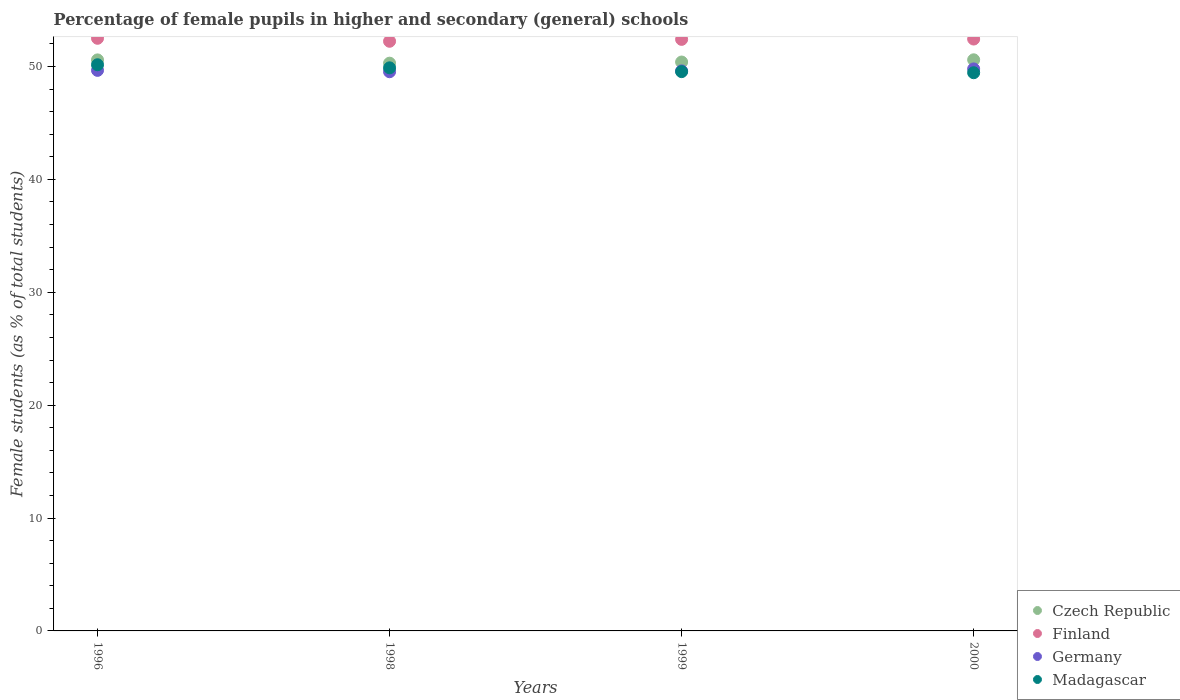What is the percentage of female pupils in higher and secondary schools in Germany in 1998?
Provide a succinct answer. 49.54. Across all years, what is the maximum percentage of female pupils in higher and secondary schools in Czech Republic?
Give a very brief answer. 50.6. Across all years, what is the minimum percentage of female pupils in higher and secondary schools in Germany?
Make the answer very short. 49.54. In which year was the percentage of female pupils in higher and secondary schools in Germany maximum?
Make the answer very short. 2000. What is the total percentage of female pupils in higher and secondary schools in Finland in the graph?
Your answer should be compact. 209.58. What is the difference between the percentage of female pupils in higher and secondary schools in Finland in 1996 and that in 1998?
Keep it short and to the point. 0.26. What is the difference between the percentage of female pupils in higher and secondary schools in Finland in 1998 and the percentage of female pupils in higher and secondary schools in Czech Republic in 1996?
Your answer should be compact. 1.65. What is the average percentage of female pupils in higher and secondary schools in Madagascar per year?
Your answer should be compact. 49.76. In the year 2000, what is the difference between the percentage of female pupils in higher and secondary schools in Czech Republic and percentage of female pupils in higher and secondary schools in Finland?
Ensure brevity in your answer.  -1.84. What is the ratio of the percentage of female pupils in higher and secondary schools in Finland in 1999 to that in 2000?
Your answer should be compact. 1. Is the percentage of female pupils in higher and secondary schools in Finland in 1999 less than that in 2000?
Your answer should be very brief. Yes. Is the difference between the percentage of female pupils in higher and secondary schools in Czech Republic in 1996 and 1998 greater than the difference between the percentage of female pupils in higher and secondary schools in Finland in 1996 and 1998?
Provide a short and direct response. Yes. What is the difference between the highest and the second highest percentage of female pupils in higher and secondary schools in Czech Republic?
Your response must be concise. 0.01. What is the difference between the highest and the lowest percentage of female pupils in higher and secondary schools in Germany?
Your response must be concise. 0.25. Is it the case that in every year, the sum of the percentage of female pupils in higher and secondary schools in Germany and percentage of female pupils in higher and secondary schools in Madagascar  is greater than the sum of percentage of female pupils in higher and secondary schools in Czech Republic and percentage of female pupils in higher and secondary schools in Finland?
Your response must be concise. No. Does the percentage of female pupils in higher and secondary schools in Madagascar monotonically increase over the years?
Provide a short and direct response. No. Is the percentage of female pupils in higher and secondary schools in Finland strictly less than the percentage of female pupils in higher and secondary schools in Czech Republic over the years?
Your answer should be very brief. No. Are the values on the major ticks of Y-axis written in scientific E-notation?
Keep it short and to the point. No. Does the graph contain grids?
Ensure brevity in your answer.  No. Where does the legend appear in the graph?
Keep it short and to the point. Bottom right. How many legend labels are there?
Offer a very short reply. 4. What is the title of the graph?
Provide a short and direct response. Percentage of female pupils in higher and secondary (general) schools. Does "Jordan" appear as one of the legend labels in the graph?
Your response must be concise. No. What is the label or title of the Y-axis?
Ensure brevity in your answer.  Female students (as % of total students). What is the Female students (as % of total students) in Czech Republic in 1996?
Your answer should be very brief. 50.59. What is the Female students (as % of total students) of Finland in 1996?
Provide a short and direct response. 52.5. What is the Female students (as % of total students) of Germany in 1996?
Your answer should be very brief. 49.66. What is the Female students (as % of total students) in Madagascar in 1996?
Give a very brief answer. 50.16. What is the Female students (as % of total students) in Czech Republic in 1998?
Offer a very short reply. 50.3. What is the Female students (as % of total students) in Finland in 1998?
Provide a short and direct response. 52.24. What is the Female students (as % of total students) in Germany in 1998?
Ensure brevity in your answer.  49.54. What is the Female students (as % of total students) in Madagascar in 1998?
Offer a very short reply. 49.88. What is the Female students (as % of total students) in Czech Republic in 1999?
Provide a succinct answer. 50.4. What is the Female students (as % of total students) in Finland in 1999?
Offer a terse response. 52.41. What is the Female students (as % of total students) in Germany in 1999?
Offer a terse response. 49.61. What is the Female students (as % of total students) in Madagascar in 1999?
Your answer should be compact. 49.55. What is the Female students (as % of total students) in Czech Republic in 2000?
Provide a succinct answer. 50.6. What is the Female students (as % of total students) in Finland in 2000?
Your answer should be compact. 52.44. What is the Female students (as % of total students) in Germany in 2000?
Make the answer very short. 49.79. What is the Female students (as % of total students) of Madagascar in 2000?
Offer a very short reply. 49.45. Across all years, what is the maximum Female students (as % of total students) of Czech Republic?
Ensure brevity in your answer.  50.6. Across all years, what is the maximum Female students (as % of total students) of Finland?
Your answer should be compact. 52.5. Across all years, what is the maximum Female students (as % of total students) in Germany?
Keep it short and to the point. 49.79. Across all years, what is the maximum Female students (as % of total students) of Madagascar?
Your response must be concise. 50.16. Across all years, what is the minimum Female students (as % of total students) in Czech Republic?
Ensure brevity in your answer.  50.3. Across all years, what is the minimum Female students (as % of total students) in Finland?
Your answer should be very brief. 52.24. Across all years, what is the minimum Female students (as % of total students) of Germany?
Make the answer very short. 49.54. Across all years, what is the minimum Female students (as % of total students) of Madagascar?
Provide a short and direct response. 49.45. What is the total Female students (as % of total students) in Czech Republic in the graph?
Provide a succinct answer. 201.88. What is the total Female students (as % of total students) of Finland in the graph?
Ensure brevity in your answer.  209.58. What is the total Female students (as % of total students) of Germany in the graph?
Provide a short and direct response. 198.6. What is the total Female students (as % of total students) of Madagascar in the graph?
Make the answer very short. 199.04. What is the difference between the Female students (as % of total students) in Czech Republic in 1996 and that in 1998?
Offer a very short reply. 0.29. What is the difference between the Female students (as % of total students) of Finland in 1996 and that in 1998?
Your answer should be compact. 0.26. What is the difference between the Female students (as % of total students) in Germany in 1996 and that in 1998?
Offer a terse response. 0.12. What is the difference between the Female students (as % of total students) in Madagascar in 1996 and that in 1998?
Your answer should be compact. 0.27. What is the difference between the Female students (as % of total students) of Czech Republic in 1996 and that in 1999?
Your answer should be compact. 0.19. What is the difference between the Female students (as % of total students) of Finland in 1996 and that in 1999?
Your answer should be very brief. 0.1. What is the difference between the Female students (as % of total students) of Germany in 1996 and that in 1999?
Ensure brevity in your answer.  0.05. What is the difference between the Female students (as % of total students) of Madagascar in 1996 and that in 1999?
Offer a terse response. 0.61. What is the difference between the Female students (as % of total students) in Czech Republic in 1996 and that in 2000?
Ensure brevity in your answer.  -0.01. What is the difference between the Female students (as % of total students) of Finland in 1996 and that in 2000?
Make the answer very short. 0.07. What is the difference between the Female students (as % of total students) of Germany in 1996 and that in 2000?
Keep it short and to the point. -0.13. What is the difference between the Female students (as % of total students) of Madagascar in 1996 and that in 2000?
Your response must be concise. 0.71. What is the difference between the Female students (as % of total students) of Czech Republic in 1998 and that in 1999?
Offer a very short reply. -0.1. What is the difference between the Female students (as % of total students) of Finland in 1998 and that in 1999?
Your response must be concise. -0.17. What is the difference between the Female students (as % of total students) in Germany in 1998 and that in 1999?
Provide a succinct answer. -0.07. What is the difference between the Female students (as % of total students) in Madagascar in 1998 and that in 1999?
Offer a terse response. 0.34. What is the difference between the Female students (as % of total students) of Czech Republic in 1998 and that in 2000?
Offer a very short reply. -0.3. What is the difference between the Female students (as % of total students) in Finland in 1998 and that in 2000?
Provide a succinct answer. -0.2. What is the difference between the Female students (as % of total students) in Madagascar in 1998 and that in 2000?
Provide a succinct answer. 0.43. What is the difference between the Female students (as % of total students) in Czech Republic in 1999 and that in 2000?
Offer a very short reply. -0.2. What is the difference between the Female students (as % of total students) of Finland in 1999 and that in 2000?
Give a very brief answer. -0.03. What is the difference between the Female students (as % of total students) in Germany in 1999 and that in 2000?
Ensure brevity in your answer.  -0.18. What is the difference between the Female students (as % of total students) in Madagascar in 1999 and that in 2000?
Your answer should be compact. 0.1. What is the difference between the Female students (as % of total students) of Czech Republic in 1996 and the Female students (as % of total students) of Finland in 1998?
Offer a very short reply. -1.65. What is the difference between the Female students (as % of total students) in Czech Republic in 1996 and the Female students (as % of total students) in Germany in 1998?
Offer a terse response. 1.05. What is the difference between the Female students (as % of total students) in Czech Republic in 1996 and the Female students (as % of total students) in Madagascar in 1998?
Keep it short and to the point. 0.7. What is the difference between the Female students (as % of total students) of Finland in 1996 and the Female students (as % of total students) of Germany in 1998?
Offer a very short reply. 2.96. What is the difference between the Female students (as % of total students) of Finland in 1996 and the Female students (as % of total students) of Madagascar in 1998?
Ensure brevity in your answer.  2.62. What is the difference between the Female students (as % of total students) in Germany in 1996 and the Female students (as % of total students) in Madagascar in 1998?
Ensure brevity in your answer.  -0.22. What is the difference between the Female students (as % of total students) in Czech Republic in 1996 and the Female students (as % of total students) in Finland in 1999?
Provide a succinct answer. -1.82. What is the difference between the Female students (as % of total students) of Czech Republic in 1996 and the Female students (as % of total students) of Germany in 1999?
Your response must be concise. 0.98. What is the difference between the Female students (as % of total students) of Czech Republic in 1996 and the Female students (as % of total students) of Madagascar in 1999?
Offer a very short reply. 1.04. What is the difference between the Female students (as % of total students) of Finland in 1996 and the Female students (as % of total students) of Germany in 1999?
Your response must be concise. 2.89. What is the difference between the Female students (as % of total students) of Finland in 1996 and the Female students (as % of total students) of Madagascar in 1999?
Your answer should be very brief. 2.95. What is the difference between the Female students (as % of total students) in Germany in 1996 and the Female students (as % of total students) in Madagascar in 1999?
Offer a very short reply. 0.11. What is the difference between the Female students (as % of total students) of Czech Republic in 1996 and the Female students (as % of total students) of Finland in 2000?
Provide a short and direct response. -1.85. What is the difference between the Female students (as % of total students) in Czech Republic in 1996 and the Female students (as % of total students) in Germany in 2000?
Provide a succinct answer. 0.8. What is the difference between the Female students (as % of total students) of Czech Republic in 1996 and the Female students (as % of total students) of Madagascar in 2000?
Give a very brief answer. 1.14. What is the difference between the Female students (as % of total students) in Finland in 1996 and the Female students (as % of total students) in Germany in 2000?
Give a very brief answer. 2.71. What is the difference between the Female students (as % of total students) in Finland in 1996 and the Female students (as % of total students) in Madagascar in 2000?
Provide a succinct answer. 3.05. What is the difference between the Female students (as % of total students) of Germany in 1996 and the Female students (as % of total students) of Madagascar in 2000?
Make the answer very short. 0.21. What is the difference between the Female students (as % of total students) in Czech Republic in 1998 and the Female students (as % of total students) in Finland in 1999?
Keep it short and to the point. -2.11. What is the difference between the Female students (as % of total students) in Czech Republic in 1998 and the Female students (as % of total students) in Germany in 1999?
Ensure brevity in your answer.  0.68. What is the difference between the Female students (as % of total students) of Czech Republic in 1998 and the Female students (as % of total students) of Madagascar in 1999?
Ensure brevity in your answer.  0.75. What is the difference between the Female students (as % of total students) in Finland in 1998 and the Female students (as % of total students) in Germany in 1999?
Provide a short and direct response. 2.62. What is the difference between the Female students (as % of total students) in Finland in 1998 and the Female students (as % of total students) in Madagascar in 1999?
Give a very brief answer. 2.69. What is the difference between the Female students (as % of total students) of Germany in 1998 and the Female students (as % of total students) of Madagascar in 1999?
Keep it short and to the point. -0.01. What is the difference between the Female students (as % of total students) in Czech Republic in 1998 and the Female students (as % of total students) in Finland in 2000?
Offer a terse response. -2.14. What is the difference between the Female students (as % of total students) in Czech Republic in 1998 and the Female students (as % of total students) in Germany in 2000?
Your answer should be compact. 0.51. What is the difference between the Female students (as % of total students) in Czech Republic in 1998 and the Female students (as % of total students) in Madagascar in 2000?
Make the answer very short. 0.85. What is the difference between the Female students (as % of total students) in Finland in 1998 and the Female students (as % of total students) in Germany in 2000?
Offer a very short reply. 2.45. What is the difference between the Female students (as % of total students) of Finland in 1998 and the Female students (as % of total students) of Madagascar in 2000?
Provide a short and direct response. 2.79. What is the difference between the Female students (as % of total students) of Germany in 1998 and the Female students (as % of total students) of Madagascar in 2000?
Ensure brevity in your answer.  0.09. What is the difference between the Female students (as % of total students) in Czech Republic in 1999 and the Female students (as % of total students) in Finland in 2000?
Your answer should be compact. -2.04. What is the difference between the Female students (as % of total students) in Czech Republic in 1999 and the Female students (as % of total students) in Germany in 2000?
Your answer should be very brief. 0.61. What is the difference between the Female students (as % of total students) of Czech Republic in 1999 and the Female students (as % of total students) of Madagascar in 2000?
Offer a very short reply. 0.95. What is the difference between the Female students (as % of total students) of Finland in 1999 and the Female students (as % of total students) of Germany in 2000?
Provide a succinct answer. 2.62. What is the difference between the Female students (as % of total students) in Finland in 1999 and the Female students (as % of total students) in Madagascar in 2000?
Ensure brevity in your answer.  2.96. What is the difference between the Female students (as % of total students) in Germany in 1999 and the Female students (as % of total students) in Madagascar in 2000?
Your response must be concise. 0.16. What is the average Female students (as % of total students) of Czech Republic per year?
Keep it short and to the point. 50.47. What is the average Female students (as % of total students) in Finland per year?
Ensure brevity in your answer.  52.4. What is the average Female students (as % of total students) of Germany per year?
Make the answer very short. 49.65. What is the average Female students (as % of total students) in Madagascar per year?
Your answer should be compact. 49.76. In the year 1996, what is the difference between the Female students (as % of total students) in Czech Republic and Female students (as % of total students) in Finland?
Offer a terse response. -1.91. In the year 1996, what is the difference between the Female students (as % of total students) in Czech Republic and Female students (as % of total students) in Germany?
Offer a very short reply. 0.93. In the year 1996, what is the difference between the Female students (as % of total students) of Czech Republic and Female students (as % of total students) of Madagascar?
Provide a short and direct response. 0.43. In the year 1996, what is the difference between the Female students (as % of total students) in Finland and Female students (as % of total students) in Germany?
Ensure brevity in your answer.  2.84. In the year 1996, what is the difference between the Female students (as % of total students) in Finland and Female students (as % of total students) in Madagascar?
Provide a succinct answer. 2.34. In the year 1996, what is the difference between the Female students (as % of total students) in Germany and Female students (as % of total students) in Madagascar?
Your answer should be very brief. -0.5. In the year 1998, what is the difference between the Female students (as % of total students) of Czech Republic and Female students (as % of total students) of Finland?
Make the answer very short. -1.94. In the year 1998, what is the difference between the Female students (as % of total students) in Czech Republic and Female students (as % of total students) in Germany?
Make the answer very short. 0.76. In the year 1998, what is the difference between the Female students (as % of total students) in Czech Republic and Female students (as % of total students) in Madagascar?
Provide a short and direct response. 0.41. In the year 1998, what is the difference between the Female students (as % of total students) of Finland and Female students (as % of total students) of Germany?
Your answer should be compact. 2.7. In the year 1998, what is the difference between the Female students (as % of total students) in Finland and Female students (as % of total students) in Madagascar?
Your answer should be very brief. 2.35. In the year 1998, what is the difference between the Female students (as % of total students) of Germany and Female students (as % of total students) of Madagascar?
Keep it short and to the point. -0.35. In the year 1999, what is the difference between the Female students (as % of total students) in Czech Republic and Female students (as % of total students) in Finland?
Your response must be concise. -2.01. In the year 1999, what is the difference between the Female students (as % of total students) in Czech Republic and Female students (as % of total students) in Germany?
Your answer should be very brief. 0.79. In the year 1999, what is the difference between the Female students (as % of total students) in Czech Republic and Female students (as % of total students) in Madagascar?
Ensure brevity in your answer.  0.85. In the year 1999, what is the difference between the Female students (as % of total students) in Finland and Female students (as % of total students) in Germany?
Offer a very short reply. 2.79. In the year 1999, what is the difference between the Female students (as % of total students) in Finland and Female students (as % of total students) in Madagascar?
Your answer should be very brief. 2.86. In the year 1999, what is the difference between the Female students (as % of total students) of Germany and Female students (as % of total students) of Madagascar?
Provide a short and direct response. 0.06. In the year 2000, what is the difference between the Female students (as % of total students) in Czech Republic and Female students (as % of total students) in Finland?
Give a very brief answer. -1.84. In the year 2000, what is the difference between the Female students (as % of total students) of Czech Republic and Female students (as % of total students) of Germany?
Your answer should be compact. 0.81. In the year 2000, what is the difference between the Female students (as % of total students) in Czech Republic and Female students (as % of total students) in Madagascar?
Make the answer very short. 1.15. In the year 2000, what is the difference between the Female students (as % of total students) in Finland and Female students (as % of total students) in Germany?
Your answer should be very brief. 2.65. In the year 2000, what is the difference between the Female students (as % of total students) in Finland and Female students (as % of total students) in Madagascar?
Ensure brevity in your answer.  2.98. In the year 2000, what is the difference between the Female students (as % of total students) of Germany and Female students (as % of total students) of Madagascar?
Your answer should be very brief. 0.34. What is the ratio of the Female students (as % of total students) in Finland in 1996 to that in 1998?
Give a very brief answer. 1. What is the ratio of the Female students (as % of total students) in Germany in 1996 to that in 1998?
Provide a succinct answer. 1. What is the ratio of the Female students (as % of total students) of Madagascar in 1996 to that in 1998?
Your answer should be very brief. 1.01. What is the ratio of the Female students (as % of total students) in Finland in 1996 to that in 1999?
Keep it short and to the point. 1. What is the ratio of the Female students (as % of total students) of Madagascar in 1996 to that in 1999?
Provide a succinct answer. 1.01. What is the ratio of the Female students (as % of total students) in Finland in 1996 to that in 2000?
Provide a succinct answer. 1. What is the ratio of the Female students (as % of total students) of Germany in 1996 to that in 2000?
Ensure brevity in your answer.  1. What is the ratio of the Female students (as % of total students) in Madagascar in 1996 to that in 2000?
Make the answer very short. 1.01. What is the ratio of the Female students (as % of total students) in Finland in 1998 to that in 1999?
Ensure brevity in your answer.  1. What is the ratio of the Female students (as % of total students) in Germany in 1998 to that in 1999?
Your answer should be compact. 1. What is the ratio of the Female students (as % of total students) in Madagascar in 1998 to that in 1999?
Ensure brevity in your answer.  1.01. What is the ratio of the Female students (as % of total students) in Czech Republic in 1998 to that in 2000?
Provide a short and direct response. 0.99. What is the ratio of the Female students (as % of total students) in Germany in 1998 to that in 2000?
Ensure brevity in your answer.  0.99. What is the ratio of the Female students (as % of total students) of Madagascar in 1998 to that in 2000?
Give a very brief answer. 1.01. What is the ratio of the Female students (as % of total students) of Germany in 1999 to that in 2000?
Give a very brief answer. 1. What is the ratio of the Female students (as % of total students) in Madagascar in 1999 to that in 2000?
Your answer should be compact. 1. What is the difference between the highest and the second highest Female students (as % of total students) of Czech Republic?
Provide a succinct answer. 0.01. What is the difference between the highest and the second highest Female students (as % of total students) in Finland?
Provide a short and direct response. 0.07. What is the difference between the highest and the second highest Female students (as % of total students) of Germany?
Provide a succinct answer. 0.13. What is the difference between the highest and the second highest Female students (as % of total students) of Madagascar?
Offer a terse response. 0.27. What is the difference between the highest and the lowest Female students (as % of total students) in Czech Republic?
Keep it short and to the point. 0.3. What is the difference between the highest and the lowest Female students (as % of total students) in Finland?
Provide a succinct answer. 0.26. What is the difference between the highest and the lowest Female students (as % of total students) of Madagascar?
Give a very brief answer. 0.71. 